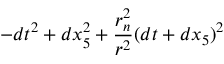Convert formula to latex. <formula><loc_0><loc_0><loc_500><loc_500>- d t ^ { 2 } + d x _ { 5 } ^ { 2 } + { \frac { r _ { n } ^ { 2 } } { r ^ { 2 } } } ( d t + d x _ { 5 } ) ^ { 2 }</formula> 